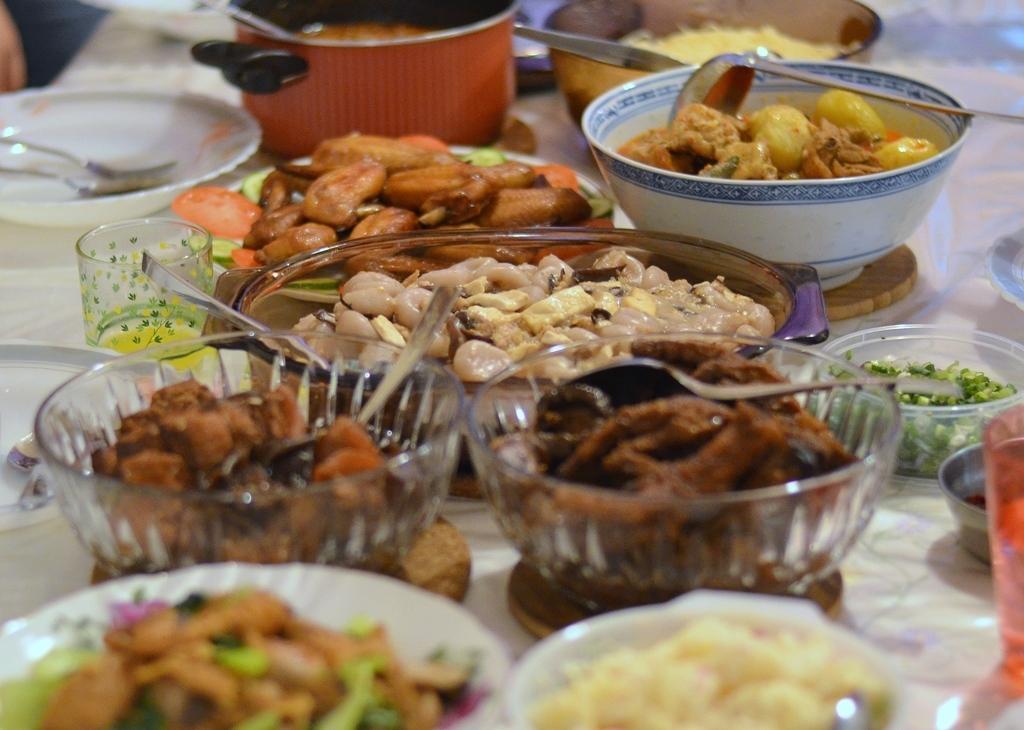Can you describe this image briefly? At the bottom of the image there is a table, on the table there are some bowls, in the bowls there is food and spoons and there are some plates, spoons, forks and glasses. 